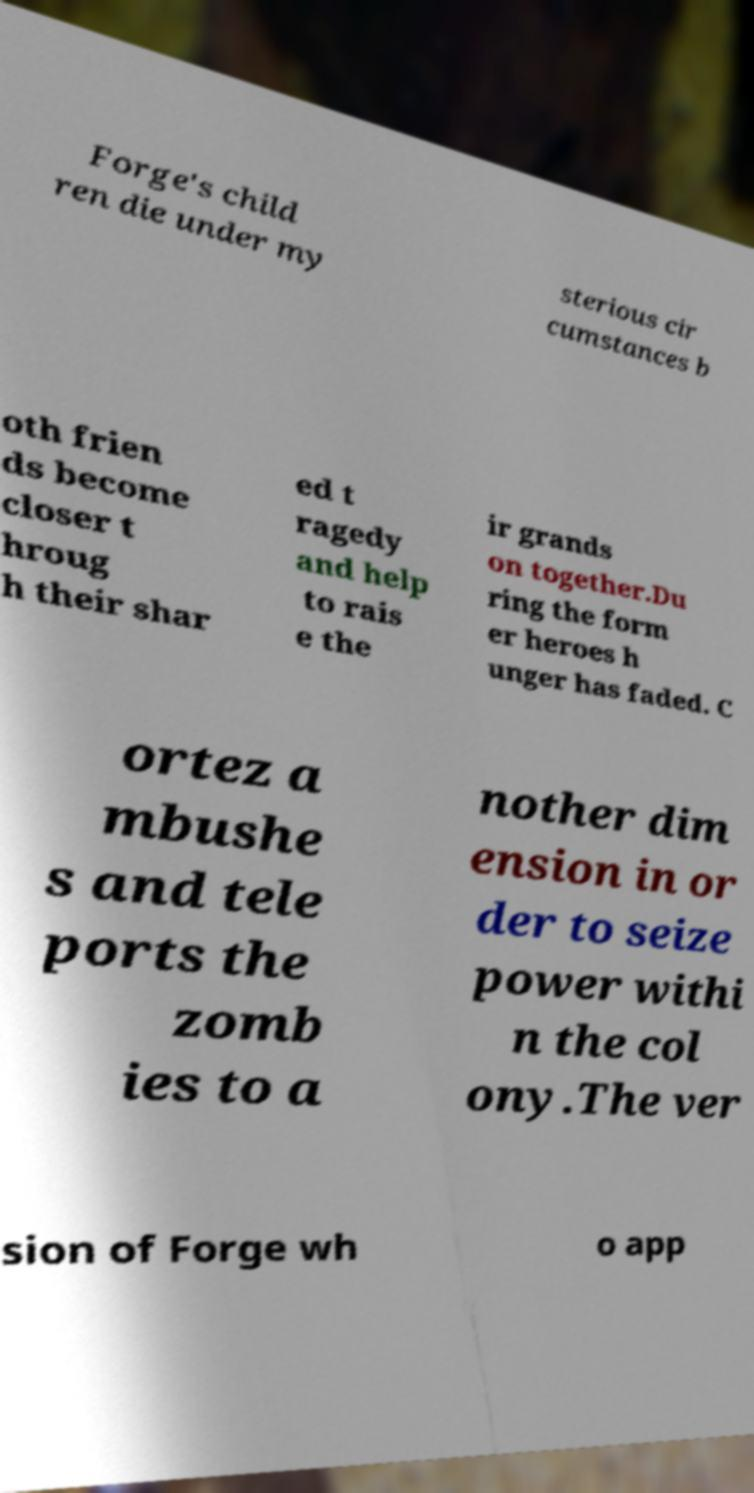Can you read and provide the text displayed in the image?This photo seems to have some interesting text. Can you extract and type it out for me? Forge's child ren die under my sterious cir cumstances b oth frien ds become closer t hroug h their shar ed t ragedy and help to rais e the ir grands on together.Du ring the form er heroes h unger has faded. C ortez a mbushe s and tele ports the zomb ies to a nother dim ension in or der to seize power withi n the col ony.The ver sion of Forge wh o app 